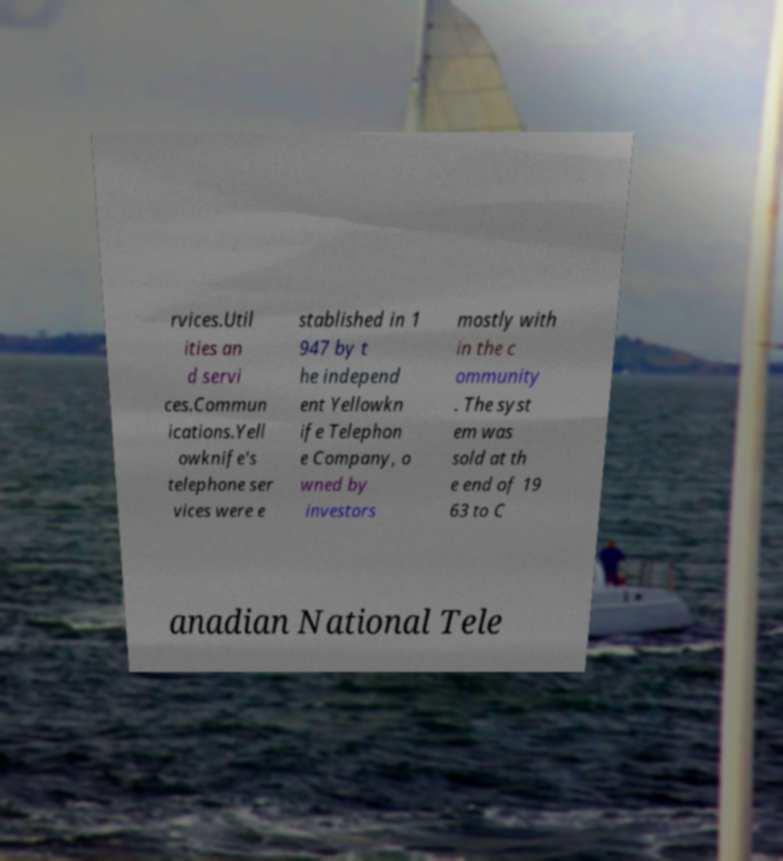For documentation purposes, I need the text within this image transcribed. Could you provide that? rvices.Util ities an d servi ces.Commun ications.Yell owknife's telephone ser vices were e stablished in 1 947 by t he independ ent Yellowkn ife Telephon e Company, o wned by investors mostly with in the c ommunity . The syst em was sold at th e end of 19 63 to C anadian National Tele 